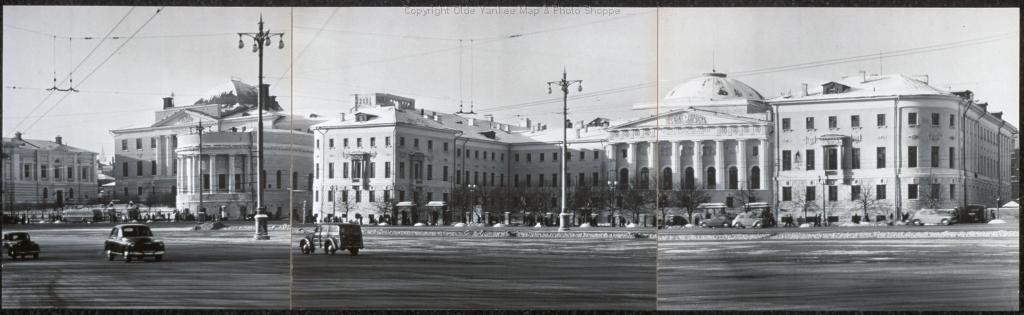Could you give a brief overview of what you see in this image? In this image I can see a poster. There are vehicles on the road. There are electric poles and wires in the center. There are buildings at the back. There is sky at the top. This is a black and white image. 